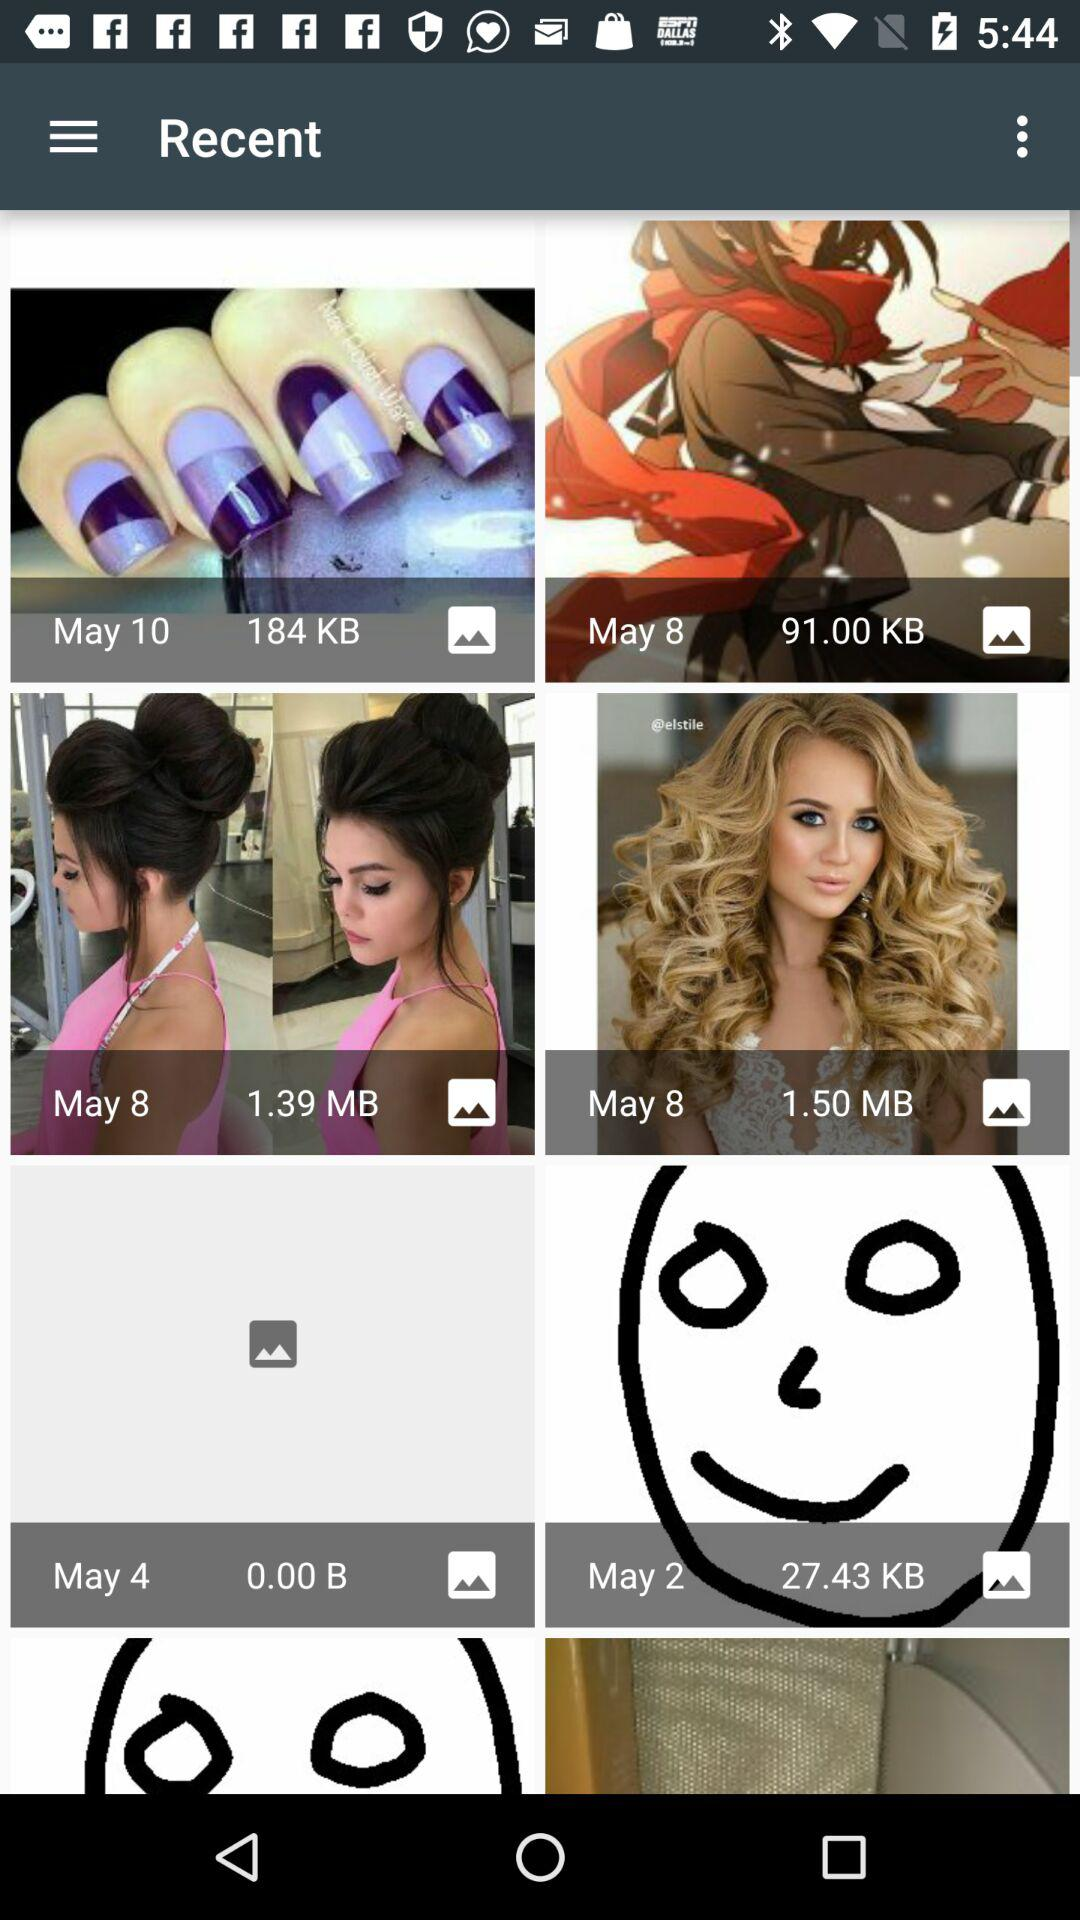What is the size of the image taken on May 10? The size of the image is 184 KB. 